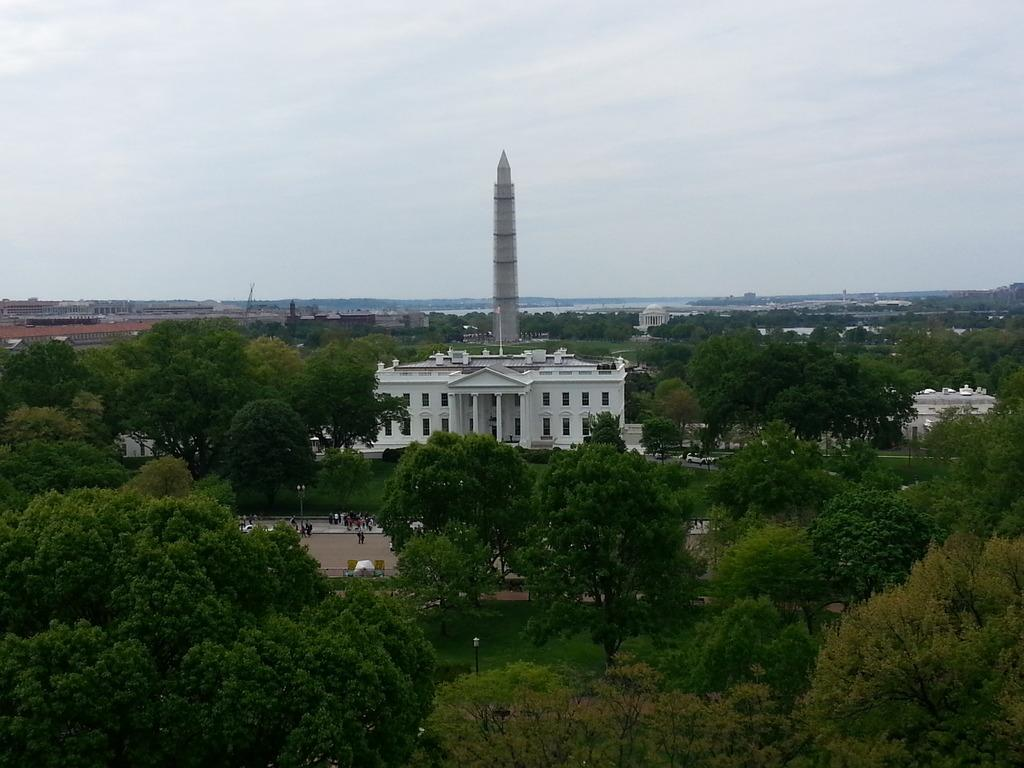What is the condition of the sky in the image? The sky is cloudy in the image. What type of structures can be seen in the image? There are buildings and a tower in the image. Who or what is present in the image? There are people in the image. What other objects can be seen in the image? There are light poles and trees in the image. Can you see the wrist of the person in the image? There is no specific person mentioned in the image, and even if there were, we cannot see their wrist from the information provided. 